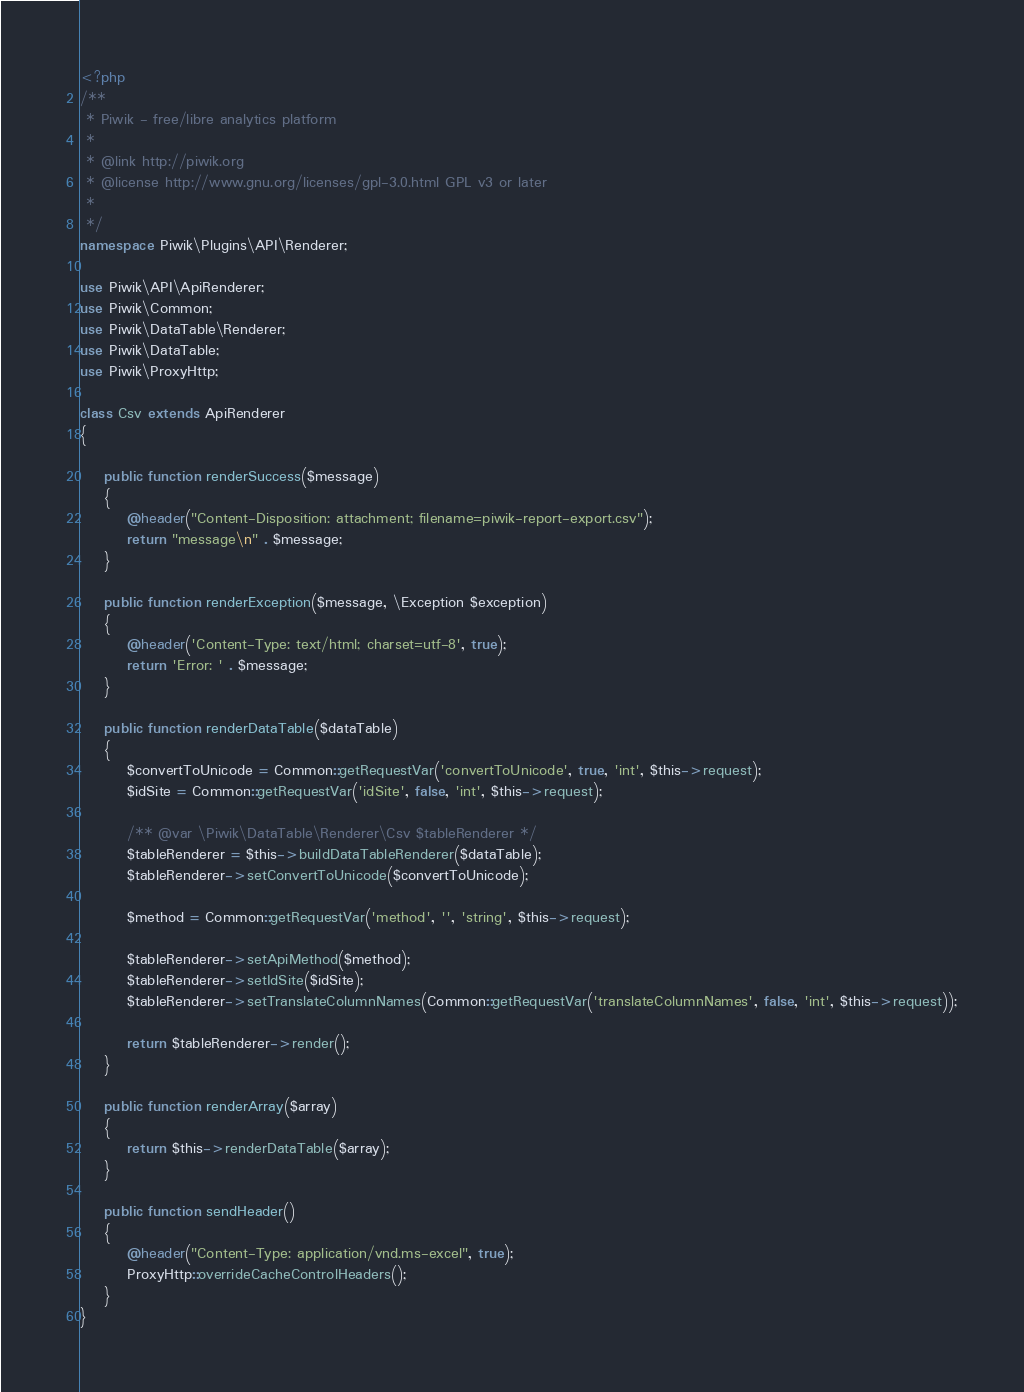Convert code to text. <code><loc_0><loc_0><loc_500><loc_500><_PHP_><?php
/**
 * Piwik - free/libre analytics platform
 *
 * @link http://piwik.org
 * @license http://www.gnu.org/licenses/gpl-3.0.html GPL v3 or later
 *
 */
namespace Piwik\Plugins\API\Renderer;

use Piwik\API\ApiRenderer;
use Piwik\Common;
use Piwik\DataTable\Renderer;
use Piwik\DataTable;
use Piwik\ProxyHttp;

class Csv extends ApiRenderer
{

    public function renderSuccess($message)
    {
        @header("Content-Disposition: attachment; filename=piwik-report-export.csv");
        return "message\n" . $message;
    }

    public function renderException($message, \Exception $exception)
    {
        @header('Content-Type: text/html; charset=utf-8', true);
        return 'Error: ' . $message;
    }

    public function renderDataTable($dataTable)
    {
        $convertToUnicode = Common::getRequestVar('convertToUnicode', true, 'int', $this->request);
        $idSite = Common::getRequestVar('idSite', false, 'int', $this->request);

        /** @var \Piwik\DataTable\Renderer\Csv $tableRenderer */
        $tableRenderer = $this->buildDataTableRenderer($dataTable);
        $tableRenderer->setConvertToUnicode($convertToUnicode);

        $method = Common::getRequestVar('method', '', 'string', $this->request);

        $tableRenderer->setApiMethod($method);
        $tableRenderer->setIdSite($idSite);
        $tableRenderer->setTranslateColumnNames(Common::getRequestVar('translateColumnNames', false, 'int', $this->request));

        return $tableRenderer->render();
    }

    public function renderArray($array)
    {
        return $this->renderDataTable($array);
    }

    public function sendHeader()
    {
        @header("Content-Type: application/vnd.ms-excel", true);
        ProxyHttp::overrideCacheControlHeaders();
    }
}
</code> 